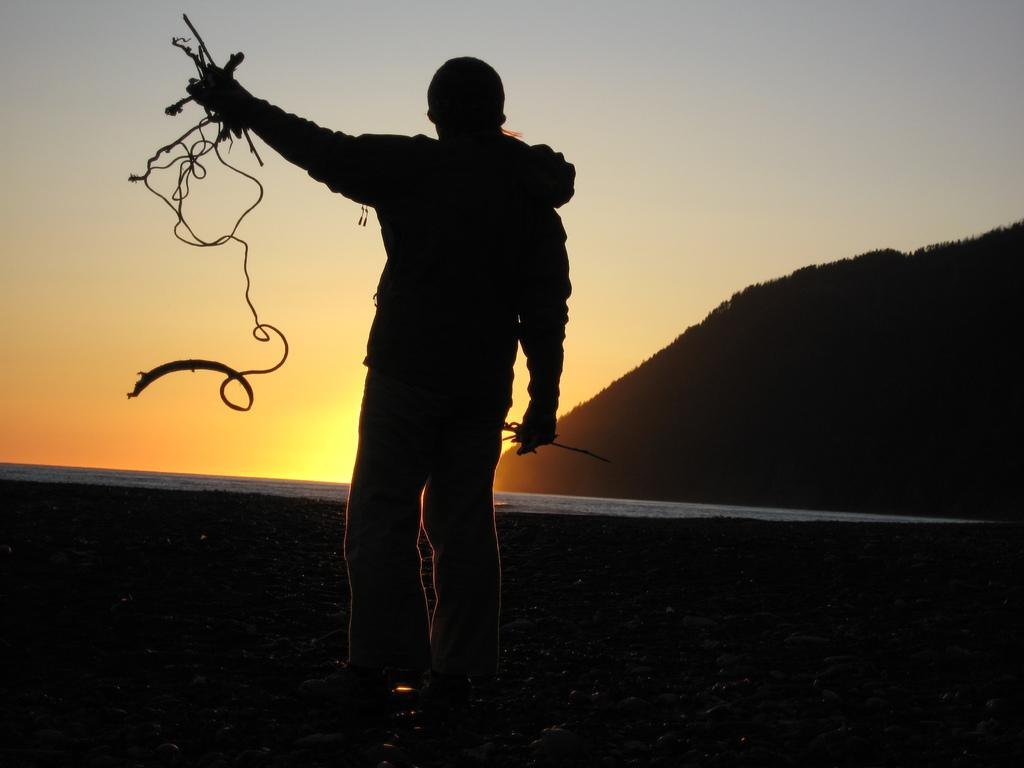What is the main subject of the image? There is a man standing in the image. What is the man holding in his hand? The man is holding wires in his hand. Where is the man located? The man is on land. What can be seen in the background of the image? There is a water surface, a mountain, and the sky visible in the background of the image. What type of ant can be seen crawling in the shade in the image? There are no ants or shaded areas present in the image. 